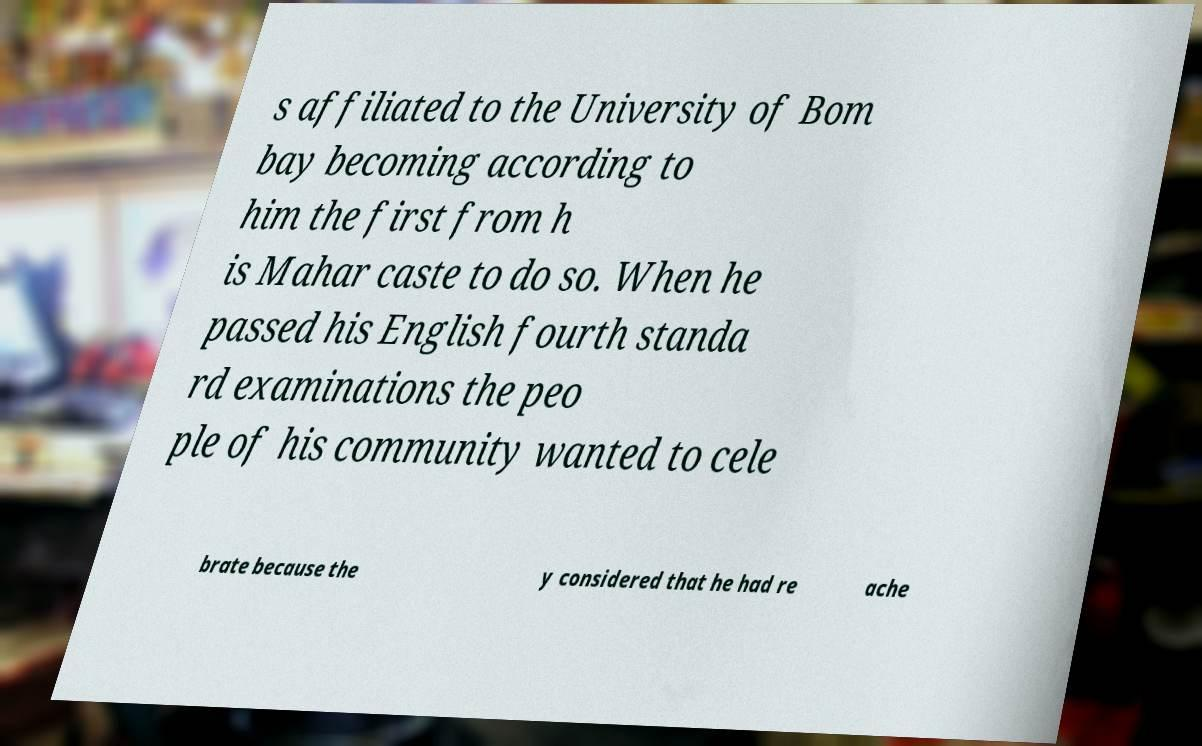What messages or text are displayed in this image? I need them in a readable, typed format. s affiliated to the University of Bom bay becoming according to him the first from h is Mahar caste to do so. When he passed his English fourth standa rd examinations the peo ple of his community wanted to cele brate because the y considered that he had re ache 